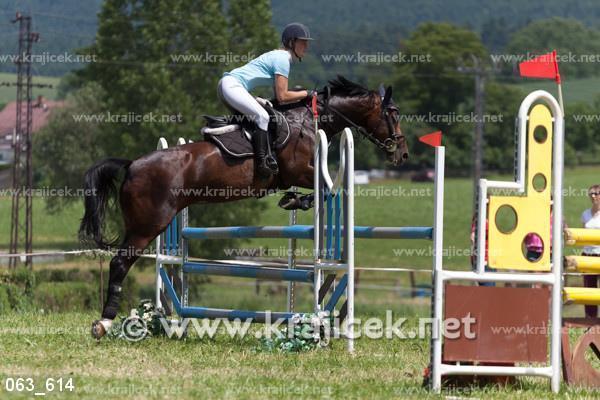What is this horse practicing?
Make your selection from the four choices given to correctly answer the question.
Options: Steeplechase, escape, posing, bucking. Steeplechase. 